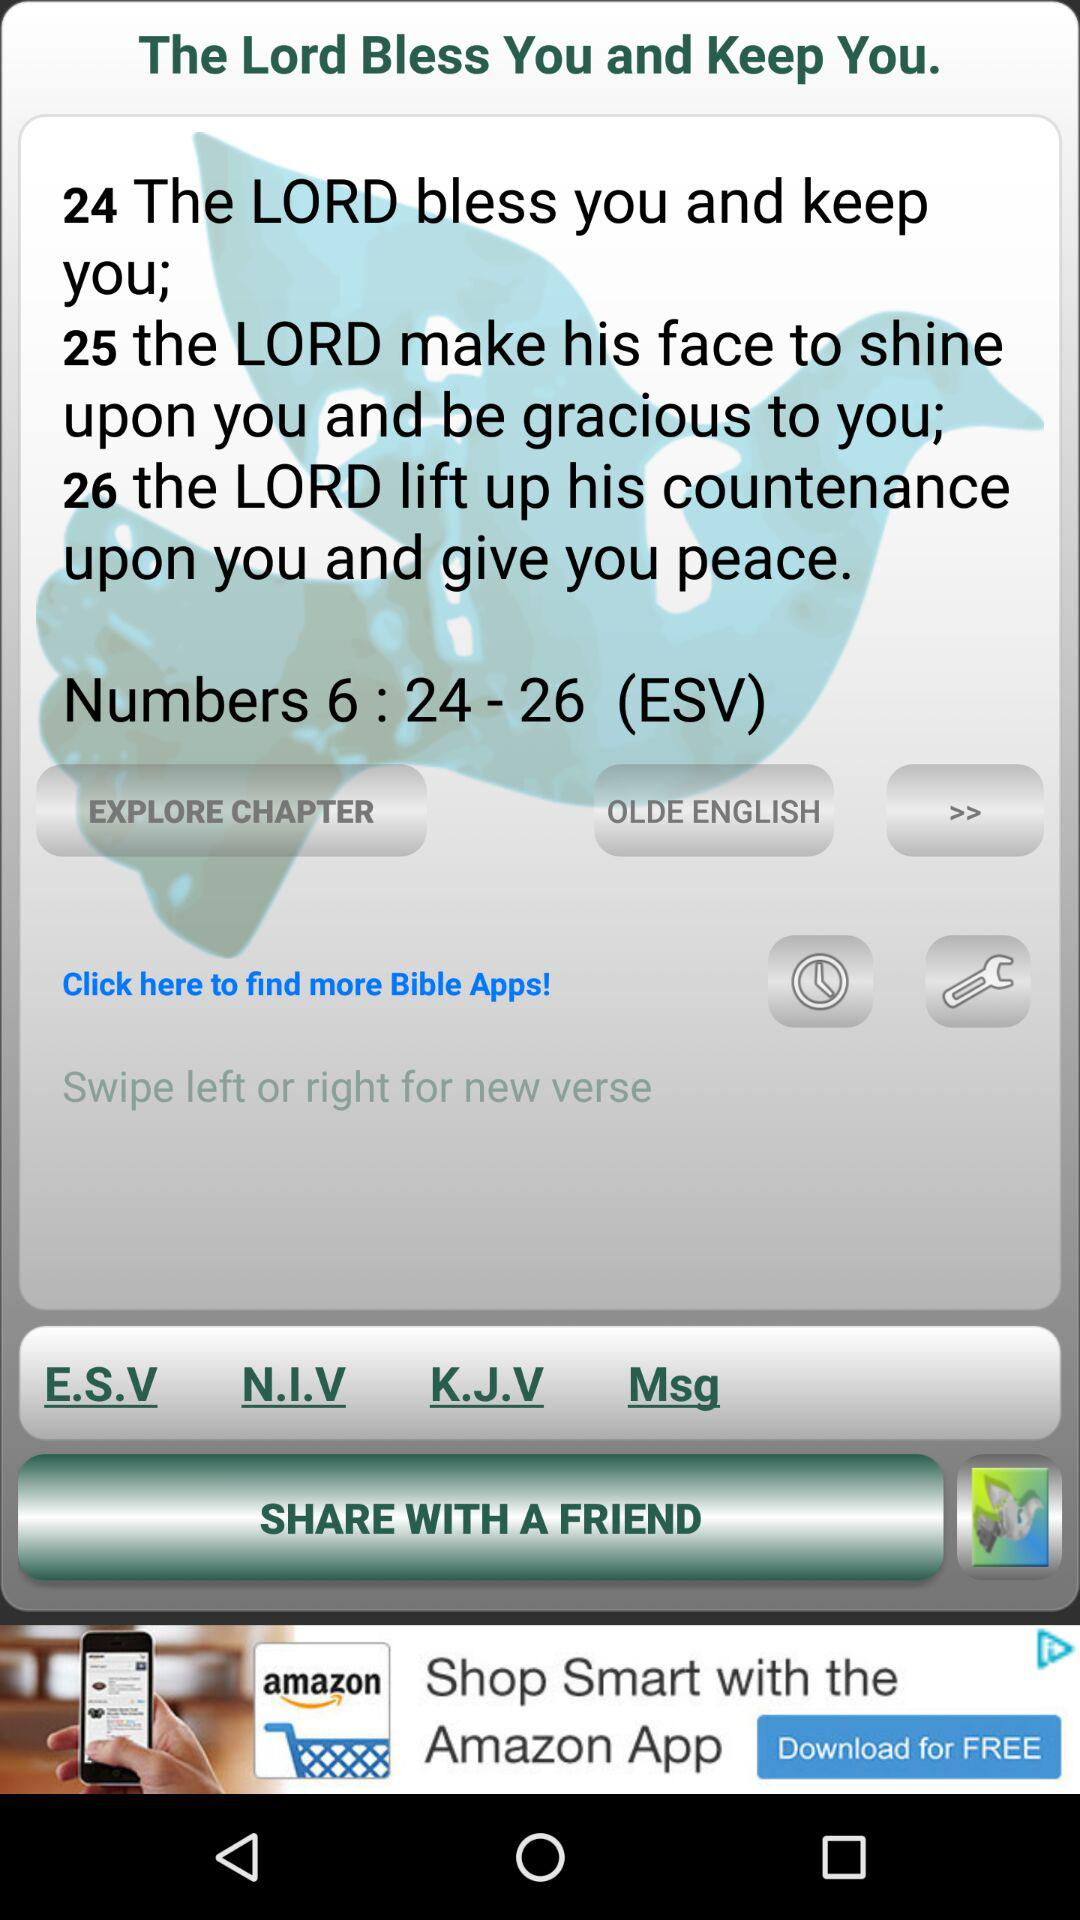How many verses are in this passage?
Answer the question using a single word or phrase. 3 